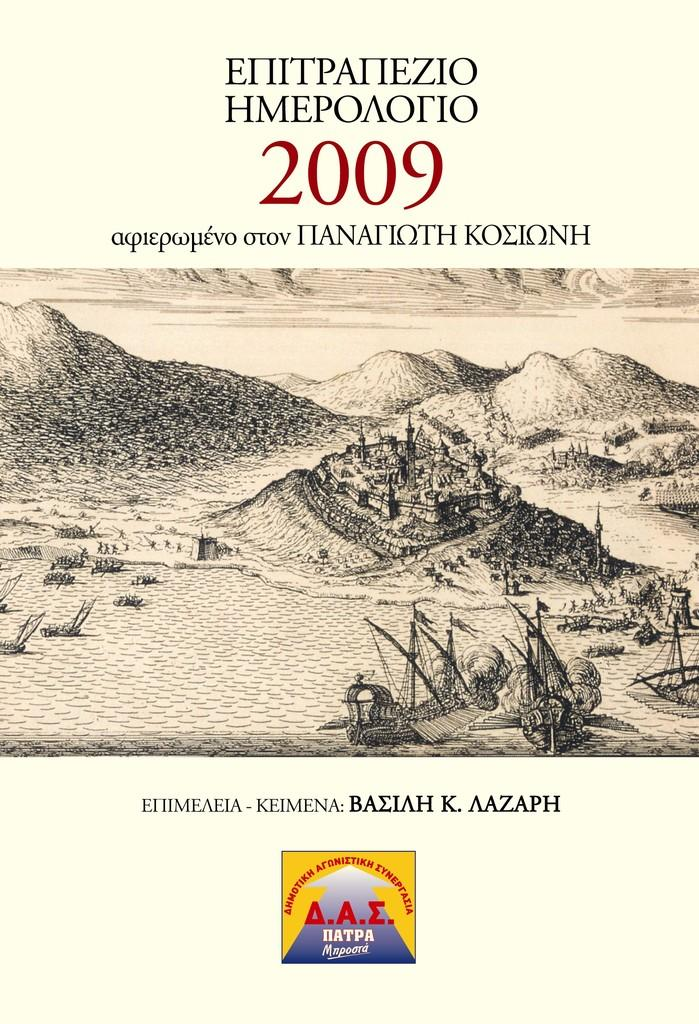<image>
Summarize the visual content of the image. a pamphlet with the year 2009 written on it 